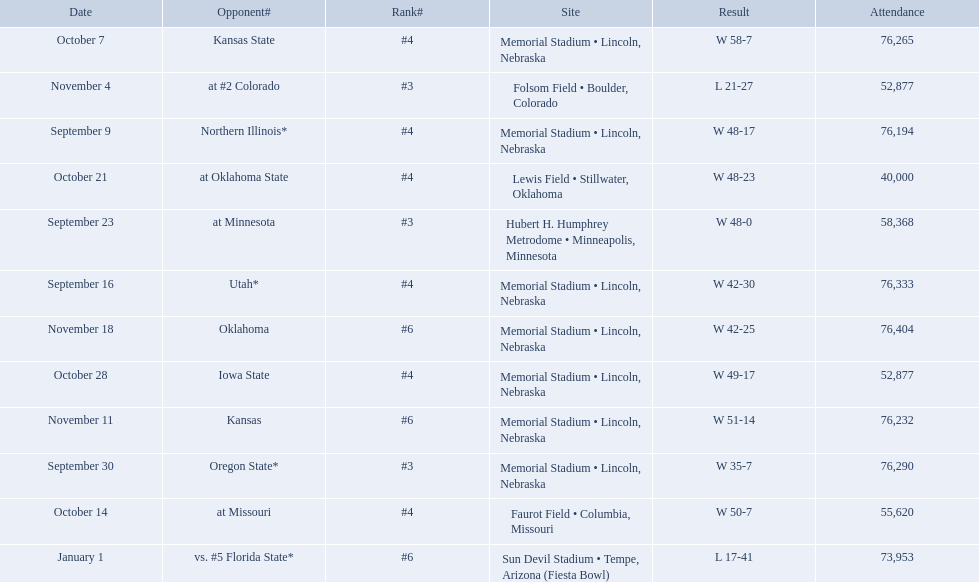Which opponenets did the nebraska cornhuskers score fewer than 40 points against? Oregon State*, at #2 Colorado, vs. #5 Florida State*. Of these games, which ones had an attendance of greater than 70,000? Oregon State*, vs. #5 Florida State*. Which of these opponents did they beat? Oregon State*. How many people were in attendance at that game? 76,290. 